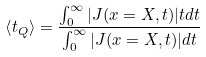Convert formula to latex. <formula><loc_0><loc_0><loc_500><loc_500>\left \langle t _ { Q } \right \rangle = \frac { \int ^ { \infty } _ { 0 } | { J } ( { x } = { X } , t ) | t d t } { \int ^ { \infty } _ { 0 } | { J } ( { x } = { X } , t ) | d t }</formula> 